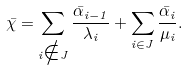Convert formula to latex. <formula><loc_0><loc_0><loc_500><loc_500>\bar { \chi } = \sum _ { i \notin J } \frac { \bar { \alpha } _ { i - 1 } } { \lambda _ { i } } + \sum _ { i \in J } \frac { \bar { \alpha } _ { i } } { \mu _ { i } } .</formula> 